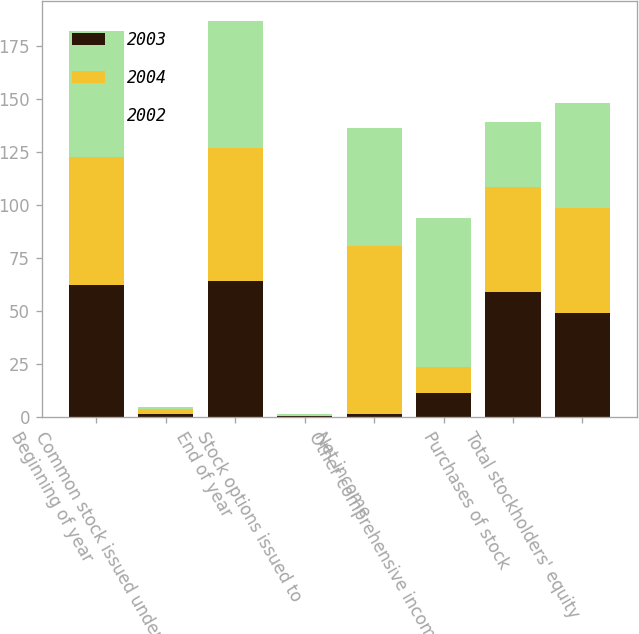Convert chart to OTSL. <chart><loc_0><loc_0><loc_500><loc_500><stacked_bar_chart><ecel><fcel>Beginning of year<fcel>Common stock issued under<fcel>End of year<fcel>Stock options issued to<fcel>Net income<fcel>Other comprehensive income<fcel>Purchases of stock<fcel>Total stockholders' equity<nl><fcel>2003<fcel>62.6<fcel>1.6<fcel>64.2<fcel>0.5<fcel>1.7<fcel>11.4<fcel>59.1<fcel>49.4<nl><fcel>2004<fcel>60.2<fcel>2.4<fcel>62.6<fcel>0.1<fcel>79<fcel>12.5<fcel>49.4<fcel>49.4<nl><fcel>2002<fcel>59.3<fcel>0.9<fcel>60.2<fcel>1.2<fcel>55.7<fcel>69.9<fcel>30.8<fcel>49.4<nl></chart> 